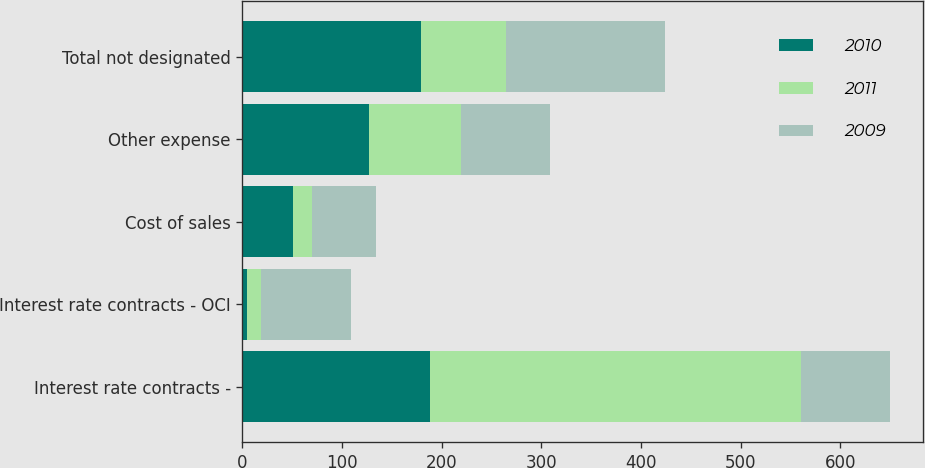<chart> <loc_0><loc_0><loc_500><loc_500><stacked_bar_chart><ecel><fcel>Interest rate contracts -<fcel>Interest rate contracts - OCI<fcel>Cost of sales<fcel>Other expense<fcel>Total not designated<nl><fcel>2010<fcel>188<fcel>5<fcel>51<fcel>127<fcel>179<nl><fcel>2011<fcel>372<fcel>14<fcel>19<fcel>92<fcel>86<nl><fcel>2009<fcel>90<fcel>90<fcel>64<fcel>90<fcel>159<nl></chart> 